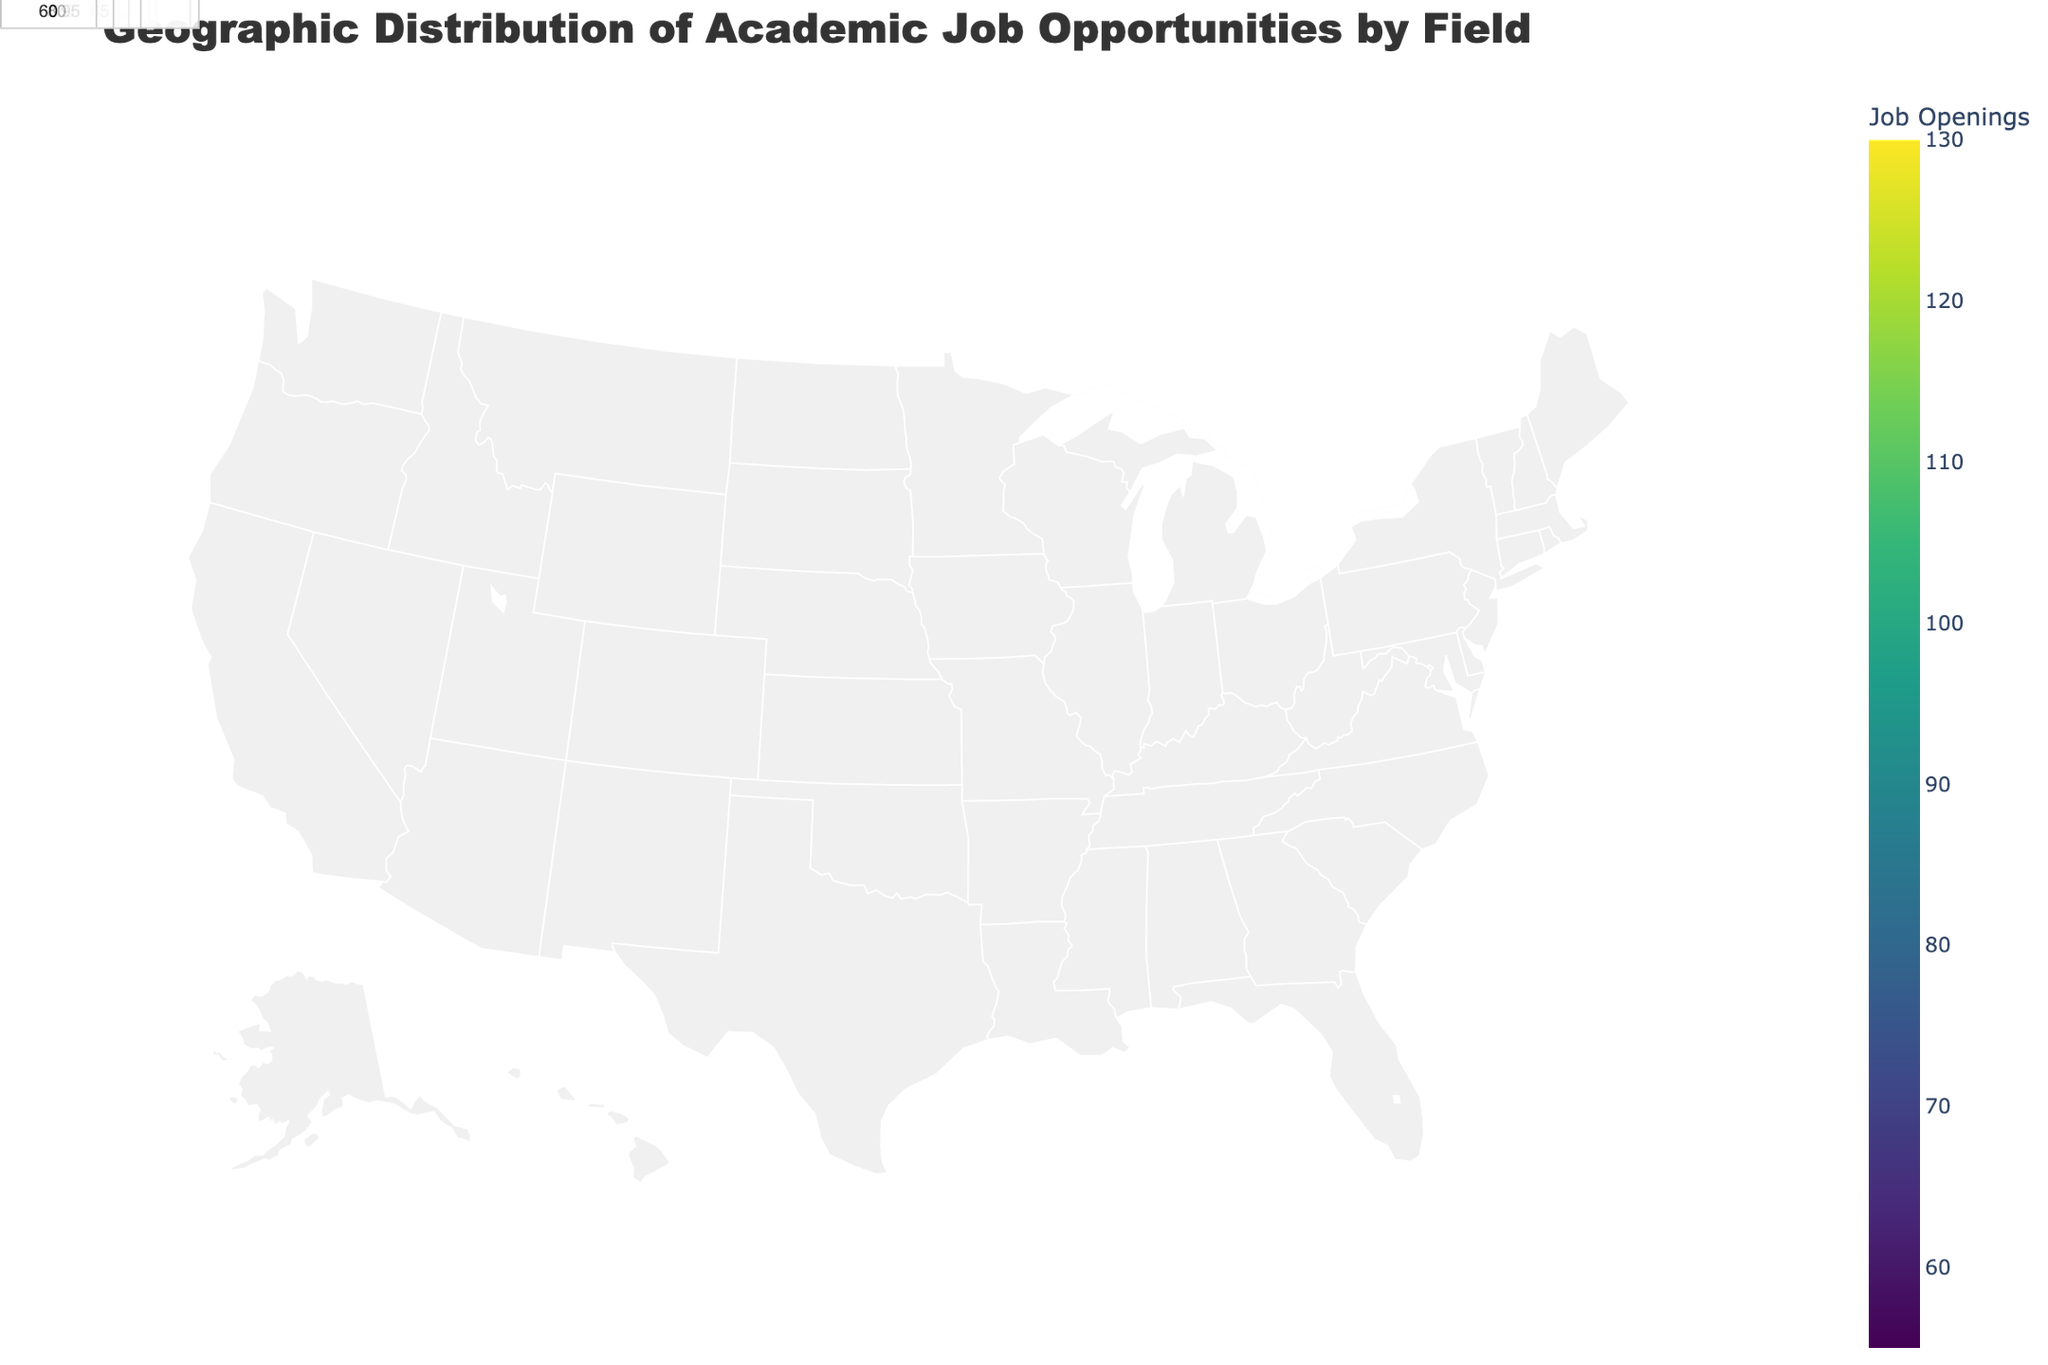What is the title of the figure? The title is usually located at the top of the figure and provides an overall description of what the figure illustrates. Here, it indicates that the figure shows the geographic distribution of academic job opportunities by field.
Answer: Geographic Distribution of Academic Job Opportunities by Field Which field has the most job openings in the Northeast? To find this, look at the annotations and hover text for the Northeast region. The field with the highest number will have the most job openings.
Answer: Computer Science What regions have job openings for Psychology? Scan the annotations or hover texts for each region. The regions indicating "Psychology" will have job openings for that field.
Answer: Midwest How many job openings are there in total in the Midwest? Sum the job openings for all fields listed under the Midwest region. These are Engineering (95), Psychology (70), and History (55). So the total is 95 + 70 + 55.
Answer: 220 Which region has more job openings, Northeast or West? Compare the sum of job openings in the Northeast (120 + 85 + 60) and the West (90 + 75 + 100). Calculate both sums. Northeast has 265, the West has 265.
Answer: They have equal openings How many fields are listed with job openings in California? Identify the number of different fields mentioned for California by looking at the annotations or hover texts.
Answer: One Which region has the highest number of job openings for a single field, and what is the field? Look for the highest number in the annotations or hover texts. The region where this highest number is found will be the one with the most job openings for a single field.
Answer: California, Data Science What's the average number of job openings per field in the South? Add up the total job openings in the South (110 + 80 + 65) and divide by the number of fields (3). The sum is 255, and the average is 255/3.
Answer: 85 What is the job opening distribution pattern for Engineering-related fields across the regions? Identify regions with fields related to Engineering and note their job openings. Engineering is in the Midwest (95), Mechanical Engineering in Texas (85). Summarize this pattern across all related regions.
Answer: Midwest: 95, Texas: 85 In which region is Environmental Science listed, and how many job openings are there for it? Look for the annotation or hover text mentioning Environmental Science and note the region and the number.
Answer: West, 100 